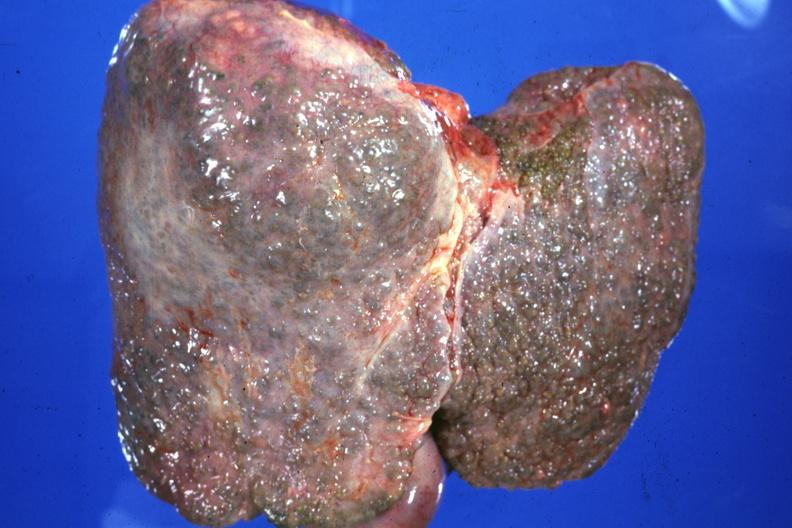what is present?
Answer the question using a single word or phrase. Hepatobiliary 